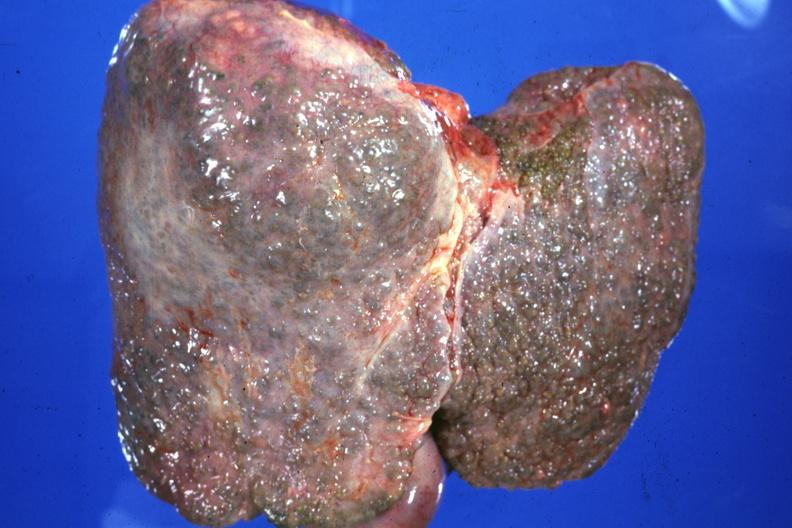what is present?
Answer the question using a single word or phrase. Hepatobiliary 